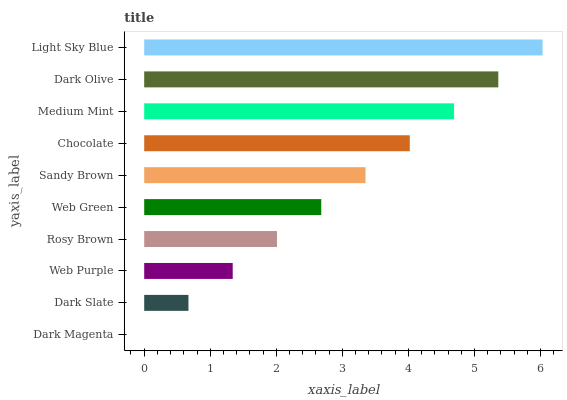Is Dark Magenta the minimum?
Answer yes or no. Yes. Is Light Sky Blue the maximum?
Answer yes or no. Yes. Is Dark Slate the minimum?
Answer yes or no. No. Is Dark Slate the maximum?
Answer yes or no. No. Is Dark Slate greater than Dark Magenta?
Answer yes or no. Yes. Is Dark Magenta less than Dark Slate?
Answer yes or no. Yes. Is Dark Magenta greater than Dark Slate?
Answer yes or no. No. Is Dark Slate less than Dark Magenta?
Answer yes or no. No. Is Sandy Brown the high median?
Answer yes or no. Yes. Is Web Green the low median?
Answer yes or no. Yes. Is Chocolate the high median?
Answer yes or no. No. Is Dark Slate the low median?
Answer yes or no. No. 